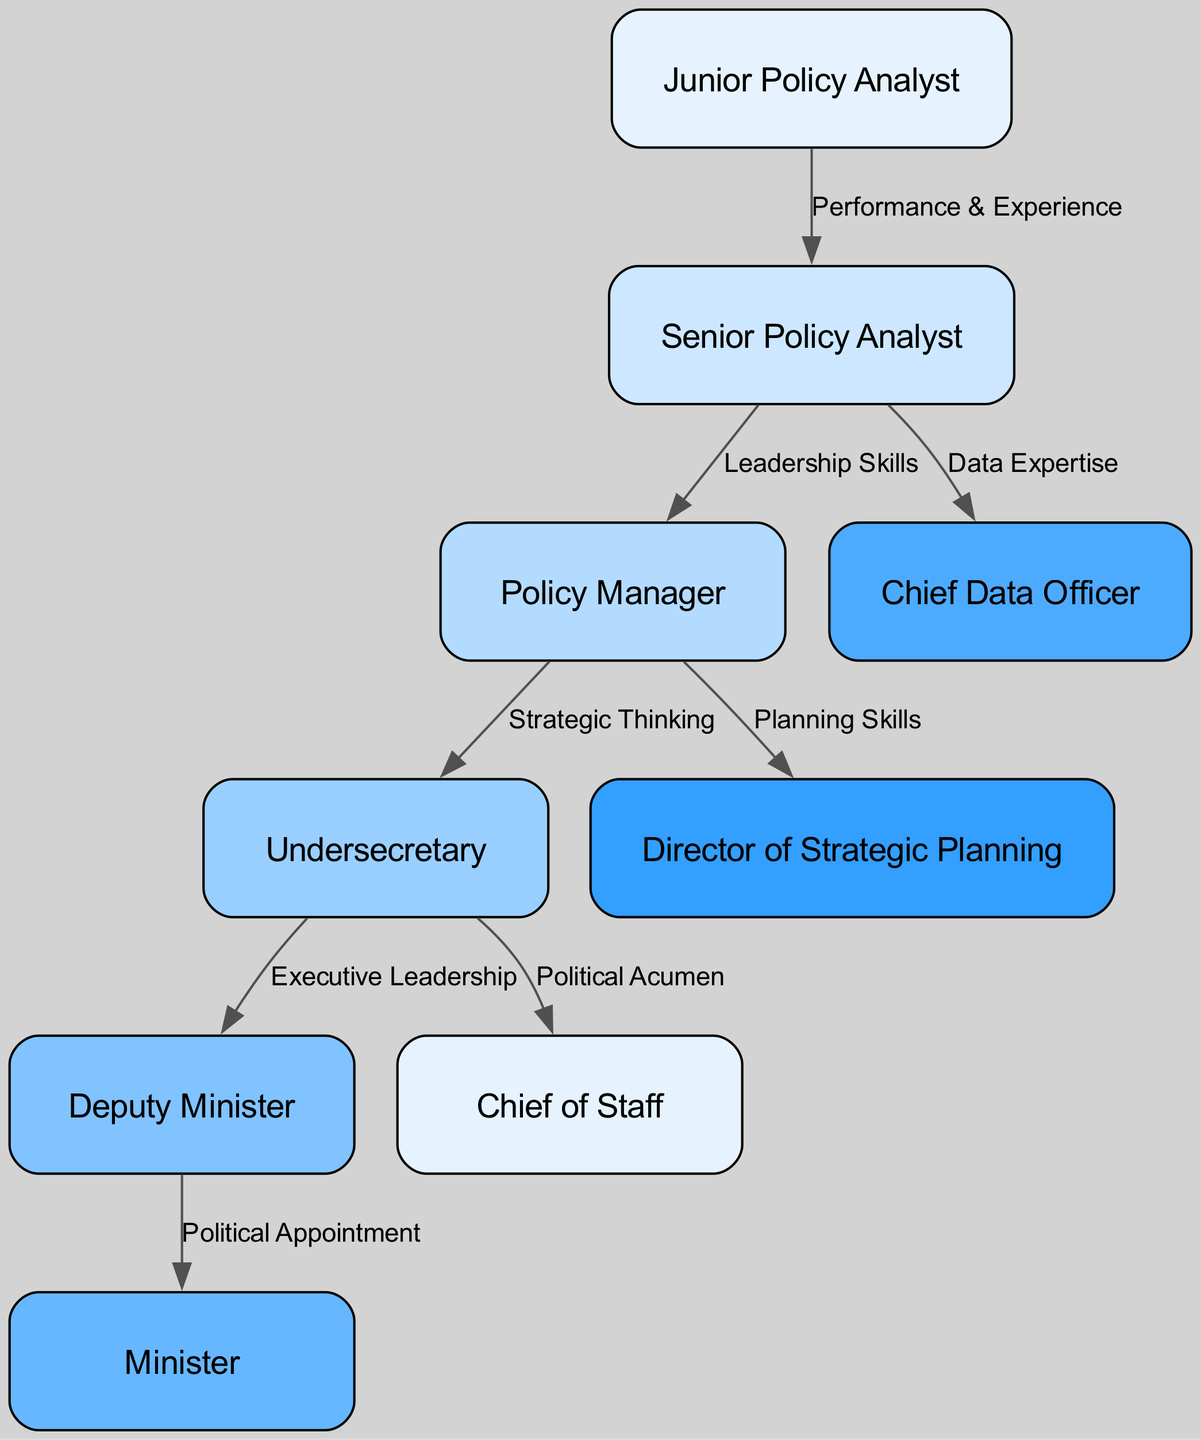What's the total number of nodes in the diagram? The nodes are listed in the diagram as the positions within the government sector. By counting each of the distinct roles mentioned (Junior Policy Analyst, Senior Policy Analyst, Policy Manager, Undersecretary, Deputy Minister, Minister, Chief Data Officer, Director of Strategic Planning, Chief of Staff), we find that there are nine nodes in total.
Answer: 9 Which node is connected to the Policy Manager? Looking at the edges in the diagram, we can trace that two nodes are connected to Policy Manager: Senior Policy Analyst, which flows into Policy Manager due to "Leadership Skills," and Undersecretary, which flows from Policy Manager due to "Strategic Thinking." Therefore, the connections are determined through these edges.
Answer: Senior Policy Analyst, Undersecretary What is the relationship between Senior Policy Analyst and Chief Data Officer? The edge labeled "Data Expertise" indicates a connection from Senior Policy Analyst to Chief Data Officer. This means that having data expertise is the reason why the Senior Policy Analyst can progress to the Chief Data Officer position.
Answer: Data Expertise What is the highest position reachable from Junior Policy Analyst? Starting from Junior Policy Analyst, the progression follows: Junior Policy Analyst → Senior Policy Analyst → Policy Manager → Undersecretary → Deputy Minister → Minister. By tracing these connections, we can see that the highest position achievable from Junior Policy Analyst is Minister.
Answer: Minister How many connections originate from the Undersecretary? By examining the diagram, we see that the Undersecretary is connected to two positions: Deputy Minister and Chief of Staff. Both connections are shown through directed edges originating from Undersecretary, indicating the possible career paths from that role. Therefore, the total number of connections is two.
Answer: 2 What skill set is required to advance from Policy Manager to Undersecretary? The edge between these two positions is labeled as "Strategic Thinking." This indicates that to advance from the Policy Manager position to the Undersecretary role, one needs to demonstrate strong strategic thinking abilities as part of the criteria for promotion.
Answer: Strategic Thinking Which two roles have no outgoing connections? When we analyze the diagram, it can be seen that the roles of Minister and Chief Data Officer have no outgoing connections to any other positions. This means they do not lead to any higher roles and represent endpoints in the career progression diagram.
Answer: Minister, Chief Data Officer 